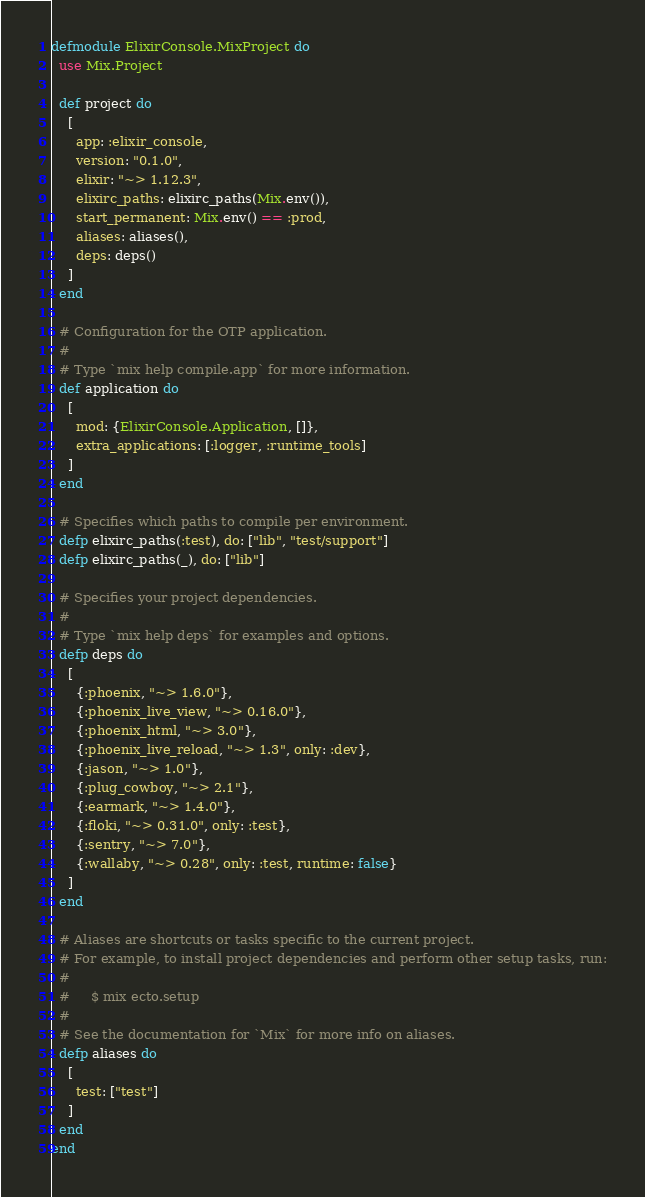Convert code to text. <code><loc_0><loc_0><loc_500><loc_500><_Elixir_>defmodule ElixirConsole.MixProject do
  use Mix.Project

  def project do
    [
      app: :elixir_console,
      version: "0.1.0",
      elixir: "~> 1.12.3",
      elixirc_paths: elixirc_paths(Mix.env()),
      start_permanent: Mix.env() == :prod,
      aliases: aliases(),
      deps: deps()
    ]
  end

  # Configuration for the OTP application.
  #
  # Type `mix help compile.app` for more information.
  def application do
    [
      mod: {ElixirConsole.Application, []},
      extra_applications: [:logger, :runtime_tools]
    ]
  end

  # Specifies which paths to compile per environment.
  defp elixirc_paths(:test), do: ["lib", "test/support"]
  defp elixirc_paths(_), do: ["lib"]

  # Specifies your project dependencies.
  #
  # Type `mix help deps` for examples and options.
  defp deps do
    [
      {:phoenix, "~> 1.6.0"},
      {:phoenix_live_view, "~> 0.16.0"},
      {:phoenix_html, "~> 3.0"},
      {:phoenix_live_reload, "~> 1.3", only: :dev},
      {:jason, "~> 1.0"},
      {:plug_cowboy, "~> 2.1"},
      {:earmark, "~> 1.4.0"},
      {:floki, "~> 0.31.0", only: :test},
      {:sentry, "~> 7.0"},
      {:wallaby, "~> 0.28", only: :test, runtime: false}
    ]
  end

  # Aliases are shortcuts or tasks specific to the current project.
  # For example, to install project dependencies and perform other setup tasks, run:
  #
  #     $ mix ecto.setup
  #
  # See the documentation for `Mix` for more info on aliases.
  defp aliases do
    [
      test: ["test"]
    ]
  end
end
</code> 